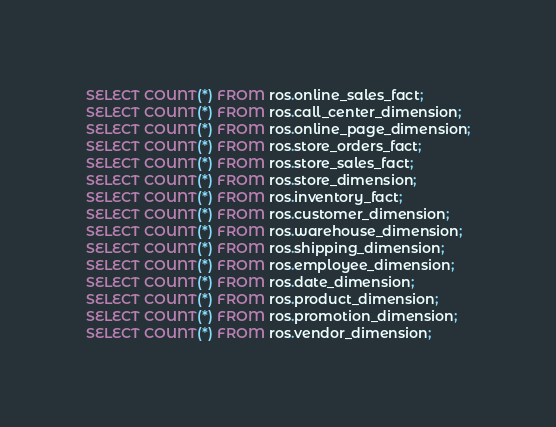Convert code to text. <code><loc_0><loc_0><loc_500><loc_500><_SQL_>SELECT COUNT(*) FROM ros.online_sales_fact;
SELECT COUNT(*) FROM ros.call_center_dimension;
SELECT COUNT(*) FROM ros.online_page_dimension;
SELECT COUNT(*) FROM ros.store_orders_fact;
SELECT COUNT(*) FROM ros.store_sales_fact;
SELECT COUNT(*) FROM ros.store_dimension;
SELECT COUNT(*) FROM ros.inventory_fact;
SELECT COUNT(*) FROM ros.customer_dimension;
SELECT COUNT(*) FROM ros.warehouse_dimension;
SELECT COUNT(*) FROM ros.shipping_dimension;
SELECT COUNT(*) FROM ros.employee_dimension;
SELECT COUNT(*) FROM ros.date_dimension;
SELECT COUNT(*) FROM ros.product_dimension;
SELECT COUNT(*) FROM ros.promotion_dimension;
SELECT COUNT(*) FROM ros.vendor_dimension;
</code> 